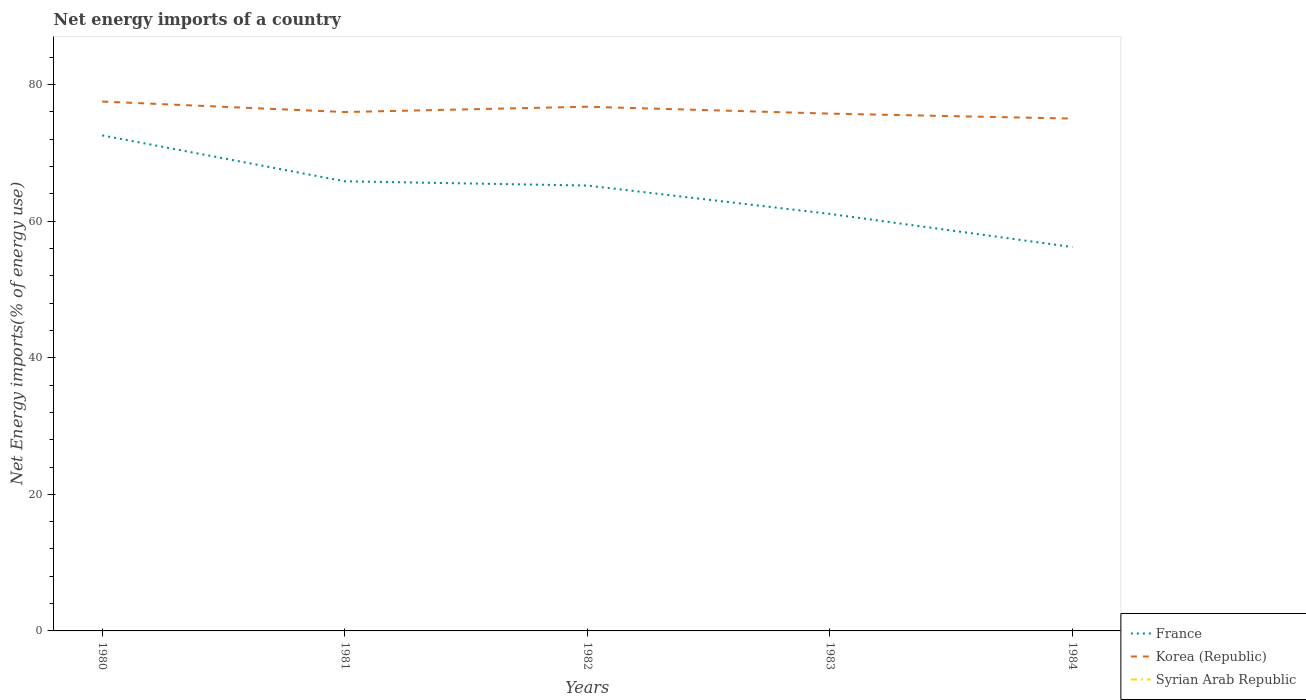What is the total net energy imports in France in the graph?
Offer a very short reply. 6.72. What is the difference between the highest and the second highest net energy imports in Korea (Republic)?
Provide a short and direct response. 2.49. What is the difference between the highest and the lowest net energy imports in Syrian Arab Republic?
Keep it short and to the point. 0. Does the graph contain any zero values?
Your answer should be compact. Yes. Does the graph contain grids?
Give a very brief answer. No. Where does the legend appear in the graph?
Your answer should be compact. Bottom right. How many legend labels are there?
Provide a succinct answer. 3. What is the title of the graph?
Make the answer very short. Net energy imports of a country. What is the label or title of the X-axis?
Provide a short and direct response. Years. What is the label or title of the Y-axis?
Provide a short and direct response. Net Energy imports(% of energy use). What is the Net Energy imports(% of energy use) in France in 1980?
Offer a terse response. 72.57. What is the Net Energy imports(% of energy use) in Korea (Republic) in 1980?
Keep it short and to the point. 77.53. What is the Net Energy imports(% of energy use) of France in 1981?
Keep it short and to the point. 65.85. What is the Net Energy imports(% of energy use) of Korea (Republic) in 1981?
Keep it short and to the point. 75.99. What is the Net Energy imports(% of energy use) in Syrian Arab Republic in 1981?
Ensure brevity in your answer.  0. What is the Net Energy imports(% of energy use) of France in 1982?
Provide a short and direct response. 65.23. What is the Net Energy imports(% of energy use) of Korea (Republic) in 1982?
Ensure brevity in your answer.  76.77. What is the Net Energy imports(% of energy use) of France in 1983?
Offer a very short reply. 61.07. What is the Net Energy imports(% of energy use) in Korea (Republic) in 1983?
Provide a short and direct response. 75.76. What is the Net Energy imports(% of energy use) in Syrian Arab Republic in 1983?
Your answer should be very brief. 0. What is the Net Energy imports(% of energy use) in France in 1984?
Your answer should be compact. 56.22. What is the Net Energy imports(% of energy use) in Korea (Republic) in 1984?
Your answer should be compact. 75.03. Across all years, what is the maximum Net Energy imports(% of energy use) of France?
Offer a very short reply. 72.57. Across all years, what is the maximum Net Energy imports(% of energy use) in Korea (Republic)?
Make the answer very short. 77.53. Across all years, what is the minimum Net Energy imports(% of energy use) of France?
Provide a succinct answer. 56.22. Across all years, what is the minimum Net Energy imports(% of energy use) of Korea (Republic)?
Provide a short and direct response. 75.03. What is the total Net Energy imports(% of energy use) in France in the graph?
Offer a terse response. 320.94. What is the total Net Energy imports(% of energy use) of Korea (Republic) in the graph?
Offer a very short reply. 381.08. What is the total Net Energy imports(% of energy use) in Syrian Arab Republic in the graph?
Provide a succinct answer. 0. What is the difference between the Net Energy imports(% of energy use) of France in 1980 and that in 1981?
Your answer should be compact. 6.72. What is the difference between the Net Energy imports(% of energy use) in Korea (Republic) in 1980 and that in 1981?
Keep it short and to the point. 1.54. What is the difference between the Net Energy imports(% of energy use) of France in 1980 and that in 1982?
Provide a short and direct response. 7.34. What is the difference between the Net Energy imports(% of energy use) of Korea (Republic) in 1980 and that in 1982?
Ensure brevity in your answer.  0.76. What is the difference between the Net Energy imports(% of energy use) of France in 1980 and that in 1983?
Offer a very short reply. 11.5. What is the difference between the Net Energy imports(% of energy use) in Korea (Republic) in 1980 and that in 1983?
Give a very brief answer. 1.77. What is the difference between the Net Energy imports(% of energy use) in France in 1980 and that in 1984?
Offer a terse response. 16.35. What is the difference between the Net Energy imports(% of energy use) in Korea (Republic) in 1980 and that in 1984?
Offer a terse response. 2.49. What is the difference between the Net Energy imports(% of energy use) in France in 1981 and that in 1982?
Offer a very short reply. 0.62. What is the difference between the Net Energy imports(% of energy use) in Korea (Republic) in 1981 and that in 1982?
Provide a succinct answer. -0.78. What is the difference between the Net Energy imports(% of energy use) in France in 1981 and that in 1983?
Ensure brevity in your answer.  4.77. What is the difference between the Net Energy imports(% of energy use) in Korea (Republic) in 1981 and that in 1983?
Your answer should be compact. 0.23. What is the difference between the Net Energy imports(% of energy use) of France in 1981 and that in 1984?
Give a very brief answer. 9.63. What is the difference between the Net Energy imports(% of energy use) of Korea (Republic) in 1981 and that in 1984?
Make the answer very short. 0.96. What is the difference between the Net Energy imports(% of energy use) in France in 1982 and that in 1983?
Give a very brief answer. 4.15. What is the difference between the Net Energy imports(% of energy use) of Korea (Republic) in 1982 and that in 1983?
Provide a succinct answer. 1.01. What is the difference between the Net Energy imports(% of energy use) in France in 1982 and that in 1984?
Provide a short and direct response. 9.01. What is the difference between the Net Energy imports(% of energy use) of Korea (Republic) in 1982 and that in 1984?
Provide a short and direct response. 1.74. What is the difference between the Net Energy imports(% of energy use) in France in 1983 and that in 1984?
Your answer should be very brief. 4.86. What is the difference between the Net Energy imports(% of energy use) in Korea (Republic) in 1983 and that in 1984?
Provide a succinct answer. 0.73. What is the difference between the Net Energy imports(% of energy use) of France in 1980 and the Net Energy imports(% of energy use) of Korea (Republic) in 1981?
Ensure brevity in your answer.  -3.42. What is the difference between the Net Energy imports(% of energy use) of France in 1980 and the Net Energy imports(% of energy use) of Korea (Republic) in 1982?
Give a very brief answer. -4.2. What is the difference between the Net Energy imports(% of energy use) in France in 1980 and the Net Energy imports(% of energy use) in Korea (Republic) in 1983?
Keep it short and to the point. -3.19. What is the difference between the Net Energy imports(% of energy use) of France in 1980 and the Net Energy imports(% of energy use) of Korea (Republic) in 1984?
Keep it short and to the point. -2.46. What is the difference between the Net Energy imports(% of energy use) of France in 1981 and the Net Energy imports(% of energy use) of Korea (Republic) in 1982?
Make the answer very short. -10.92. What is the difference between the Net Energy imports(% of energy use) in France in 1981 and the Net Energy imports(% of energy use) in Korea (Republic) in 1983?
Offer a very short reply. -9.91. What is the difference between the Net Energy imports(% of energy use) in France in 1981 and the Net Energy imports(% of energy use) in Korea (Republic) in 1984?
Your answer should be compact. -9.19. What is the difference between the Net Energy imports(% of energy use) in France in 1982 and the Net Energy imports(% of energy use) in Korea (Republic) in 1983?
Your answer should be compact. -10.53. What is the difference between the Net Energy imports(% of energy use) of France in 1982 and the Net Energy imports(% of energy use) of Korea (Republic) in 1984?
Make the answer very short. -9.81. What is the difference between the Net Energy imports(% of energy use) in France in 1983 and the Net Energy imports(% of energy use) in Korea (Republic) in 1984?
Offer a terse response. -13.96. What is the average Net Energy imports(% of energy use) in France per year?
Give a very brief answer. 64.19. What is the average Net Energy imports(% of energy use) of Korea (Republic) per year?
Provide a short and direct response. 76.22. In the year 1980, what is the difference between the Net Energy imports(% of energy use) of France and Net Energy imports(% of energy use) of Korea (Republic)?
Provide a succinct answer. -4.96. In the year 1981, what is the difference between the Net Energy imports(% of energy use) in France and Net Energy imports(% of energy use) in Korea (Republic)?
Keep it short and to the point. -10.14. In the year 1982, what is the difference between the Net Energy imports(% of energy use) of France and Net Energy imports(% of energy use) of Korea (Republic)?
Your response must be concise. -11.54. In the year 1983, what is the difference between the Net Energy imports(% of energy use) in France and Net Energy imports(% of energy use) in Korea (Republic)?
Make the answer very short. -14.68. In the year 1984, what is the difference between the Net Energy imports(% of energy use) in France and Net Energy imports(% of energy use) in Korea (Republic)?
Make the answer very short. -18.81. What is the ratio of the Net Energy imports(% of energy use) in France in 1980 to that in 1981?
Offer a terse response. 1.1. What is the ratio of the Net Energy imports(% of energy use) of Korea (Republic) in 1980 to that in 1981?
Offer a terse response. 1.02. What is the ratio of the Net Energy imports(% of energy use) in France in 1980 to that in 1982?
Ensure brevity in your answer.  1.11. What is the ratio of the Net Energy imports(% of energy use) in Korea (Republic) in 1980 to that in 1982?
Ensure brevity in your answer.  1.01. What is the ratio of the Net Energy imports(% of energy use) in France in 1980 to that in 1983?
Provide a succinct answer. 1.19. What is the ratio of the Net Energy imports(% of energy use) in Korea (Republic) in 1980 to that in 1983?
Ensure brevity in your answer.  1.02. What is the ratio of the Net Energy imports(% of energy use) of France in 1980 to that in 1984?
Ensure brevity in your answer.  1.29. What is the ratio of the Net Energy imports(% of energy use) in Korea (Republic) in 1980 to that in 1984?
Ensure brevity in your answer.  1.03. What is the ratio of the Net Energy imports(% of energy use) of France in 1981 to that in 1982?
Make the answer very short. 1.01. What is the ratio of the Net Energy imports(% of energy use) of Korea (Republic) in 1981 to that in 1982?
Give a very brief answer. 0.99. What is the ratio of the Net Energy imports(% of energy use) in France in 1981 to that in 1983?
Provide a succinct answer. 1.08. What is the ratio of the Net Energy imports(% of energy use) in France in 1981 to that in 1984?
Make the answer very short. 1.17. What is the ratio of the Net Energy imports(% of energy use) of Korea (Republic) in 1981 to that in 1984?
Make the answer very short. 1.01. What is the ratio of the Net Energy imports(% of energy use) of France in 1982 to that in 1983?
Offer a terse response. 1.07. What is the ratio of the Net Energy imports(% of energy use) of Korea (Republic) in 1982 to that in 1983?
Make the answer very short. 1.01. What is the ratio of the Net Energy imports(% of energy use) of France in 1982 to that in 1984?
Provide a succinct answer. 1.16. What is the ratio of the Net Energy imports(% of energy use) in Korea (Republic) in 1982 to that in 1984?
Provide a succinct answer. 1.02. What is the ratio of the Net Energy imports(% of energy use) of France in 1983 to that in 1984?
Provide a short and direct response. 1.09. What is the ratio of the Net Energy imports(% of energy use) in Korea (Republic) in 1983 to that in 1984?
Offer a very short reply. 1.01. What is the difference between the highest and the second highest Net Energy imports(% of energy use) of France?
Offer a very short reply. 6.72. What is the difference between the highest and the second highest Net Energy imports(% of energy use) in Korea (Republic)?
Make the answer very short. 0.76. What is the difference between the highest and the lowest Net Energy imports(% of energy use) in France?
Your response must be concise. 16.35. What is the difference between the highest and the lowest Net Energy imports(% of energy use) of Korea (Republic)?
Give a very brief answer. 2.49. 